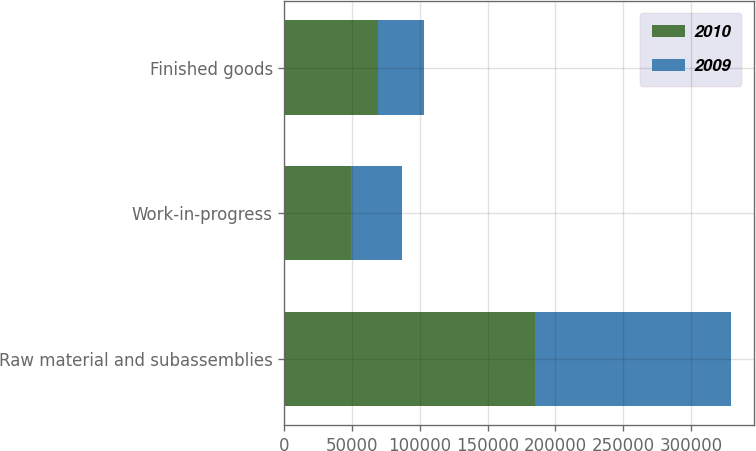Convert chart. <chart><loc_0><loc_0><loc_500><loc_500><stacked_bar_chart><ecel><fcel>Raw material and subassemblies<fcel>Work-in-progress<fcel>Finished goods<nl><fcel>2010<fcel>185359<fcel>48788<fcel>69009<nl><fcel>2009<fcel>144555<fcel>37732<fcel>34213<nl></chart> 